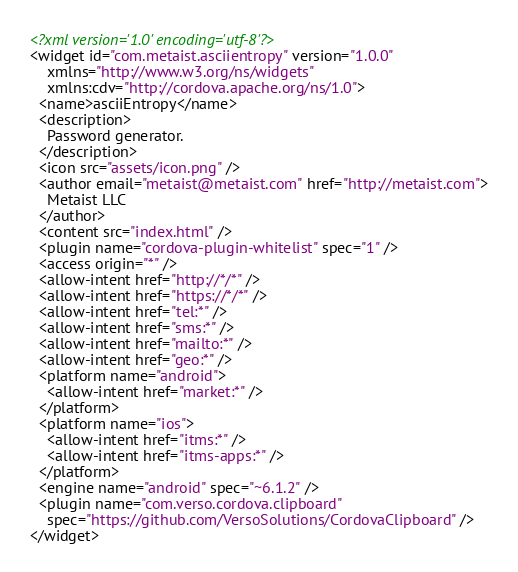Convert code to text. <code><loc_0><loc_0><loc_500><loc_500><_XML_><?xml version='1.0' encoding='utf-8'?>
<widget id="com.metaist.asciientropy" version="1.0.0"
    xmlns="http://www.w3.org/ns/widgets"
    xmlns:cdv="http://cordova.apache.org/ns/1.0">
  <name>asciiEntropy</name>
  <description>
    Password generator.
  </description>
  <icon src="assets/icon.png" />
  <author email="metaist@metaist.com" href="http://metaist.com">
    Metaist LLC
  </author>
  <content src="index.html" />
  <plugin name="cordova-plugin-whitelist" spec="1" />
  <access origin="*" />
  <allow-intent href="http://*/*" />
  <allow-intent href="https://*/*" />
  <allow-intent href="tel:*" />
  <allow-intent href="sms:*" />
  <allow-intent href="mailto:*" />
  <allow-intent href="geo:*" />
  <platform name="android">
    <allow-intent href="market:*" />
  </platform>
  <platform name="ios">
    <allow-intent href="itms:*" />
    <allow-intent href="itms-apps:*" />
  </platform>
  <engine name="android" spec="~6.1.2" />
  <plugin name="com.verso.cordova.clipboard"
    spec="https://github.com/VersoSolutions/CordovaClipboard" />
</widget>
</code> 